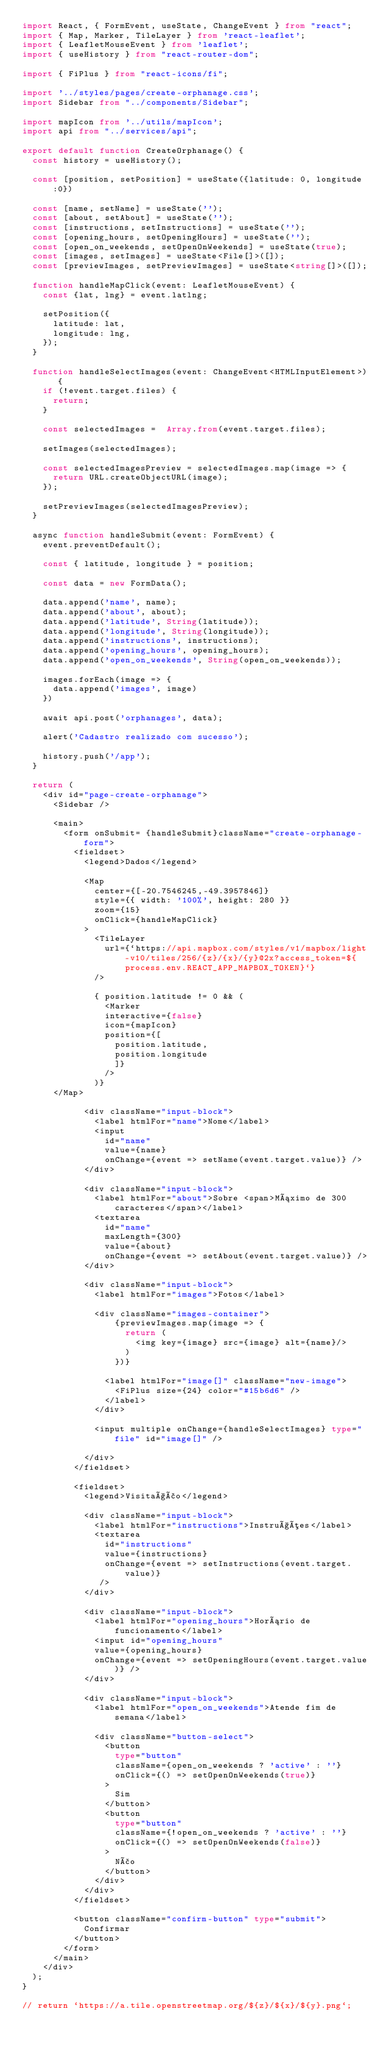Convert code to text. <code><loc_0><loc_0><loc_500><loc_500><_TypeScript_>import React, { FormEvent, useState, ChangeEvent } from "react";
import { Map, Marker, TileLayer } from 'react-leaflet';
import { LeafletMouseEvent } from 'leaflet';
import { useHistory } from "react-router-dom";

import { FiPlus } from "react-icons/fi";

import '../styles/pages/create-orphanage.css';
import Sidebar from "../components/Sidebar";

import mapIcon from '../utils/mapIcon';
import api from "../services/api";

export default function CreateOrphanage() {
  const history = useHistory();

  const [position, setPosition] = useState({latitude: 0, longitude:0})

  const [name, setName] = useState('');
  const [about, setAbout] = useState('');
  const [instructions, setInstructions] = useState('');
  const [opening_hours, setOpeningHours] = useState('');
  const [open_on_weekends, setOpenOnWeekends] = useState(true);
  const [images, setImages] = useState<File[]>([]);
  const [previewImages, setPreviewImages] = useState<string[]>([]);

  function handleMapClick(event: LeafletMouseEvent) {
    const {lat, lng} = event.latlng;

    setPosition({
      latitude: lat,
      longitude: lng,
    });
  }

  function handleSelectImages(event: ChangeEvent<HTMLInputElement>) {
    if (!event.target.files) {
      return;
    }

    const selectedImages =  Array.from(event.target.files);

    setImages(selectedImages);

    const selectedImagesPreview = selectedImages.map(image => {
      return URL.createObjectURL(image);
    });

    setPreviewImages(selectedImagesPreview);
  }

  async function handleSubmit(event: FormEvent) {
    event.preventDefault();

    const { latitude, longitude } = position;

    const data = new FormData();

    data.append('name', name);
    data.append('about', about);
    data.append('latitude', String(latitude));
    data.append('longitude', String(longitude));
    data.append('instructions', instructions);
    data.append('opening_hours', opening_hours);
    data.append('open_on_weekends', String(open_on_weekends));
    
    images.forEach(image => {
      data.append('images', image)
    })

    await api.post('orphanages', data);

    alert('Cadastro realizado com sucesso');

    history.push('/app');
  }

  return (
    <div id="page-create-orphanage">
      <Sidebar />

      <main>
        <form onSubmit= {handleSubmit}className="create-orphanage-form">
          <fieldset>
            <legend>Dados</legend>

            <Map 
              center={[-20.7546245,-49.3957846]} 
              style={{ width: '100%', height: 280 }}
              zoom={15}
              onClick={handleMapClick}
            >
              <TileLayer 
                url={`https://api.mapbox.com/styles/v1/mapbox/light-v10/tiles/256/{z}/{x}/{y}@2x?access_token=${process.env.REACT_APP_MAPBOX_TOKEN}`}
              />

              { position.latitude != 0 && (
                <Marker 
                interactive={false} 
                icon={mapIcon} 
                position={[
                  position.latitude, 
                  position.longitude
                  ]} 
                /> 
              )}
      </Map>

            <div className="input-block">
              <label htmlFor="name">Nome</label>
              <input 
                id="name" 
                value={name} 
                onChange={event => setName(event.target.value)} />
            </div>

            <div className="input-block">
              <label htmlFor="about">Sobre <span>Máximo de 300 caracteres</span></label>
              <textarea 
                id="name" 
                maxLength={300}
                value={about} 
                onChange={event => setAbout(event.target.value)} />
            </div>

            <div className="input-block">
              <label htmlFor="images">Fotos</label>

              <div className="images-container">
                  {previewImages.map(image => {
                    return (
                      <img key={image} src={image} alt={name}/>
                    )
                  })}

                <label htmlFor="image[]" className="new-image">
                  <FiPlus size={24} color="#15b6d6" />
                </label>
              </div>
              
              <input multiple onChange={handleSelectImages} type="file" id="image[]" />
            
            </div>
          </fieldset>

          <fieldset>
            <legend>Visitação</legend>

            <div className="input-block">
              <label htmlFor="instructions">Instruções</label>
              <textarea 
                id="instructions"
                value={instructions}
                onChange={event => setInstructions(event.target.value)}
               />
            </div>

            <div className="input-block">
              <label htmlFor="opening_hours">Horário de funcionamento</label>
              <input id="opening_hours"
              value={opening_hours} 
              onChange={event => setOpeningHours(event.target.value)} />
            </div>

            <div className="input-block">
              <label htmlFor="open_on_weekends">Atende fim de semana</label>

              <div className="button-select">
                <button 
                  type="button" 
                  className={open_on_weekends ? 'active' : ''}
                  onClick={() => setOpenOnWeekends(true)}
                >
                  Sim
                </button>
                <button 
                  type="button"
                  className={!open_on_weekends ? 'active' : ''}
                  onClick={() => setOpenOnWeekends(false)}
                >
                  Não
                </button>
              </div>
            </div>
          </fieldset>

          <button className="confirm-button" type="submit">
            Confirmar
          </button>
        </form>
      </main>
    </div>
  );
}

// return `https://a.tile.openstreetmap.org/${z}/${x}/${y}.png`;
</code> 